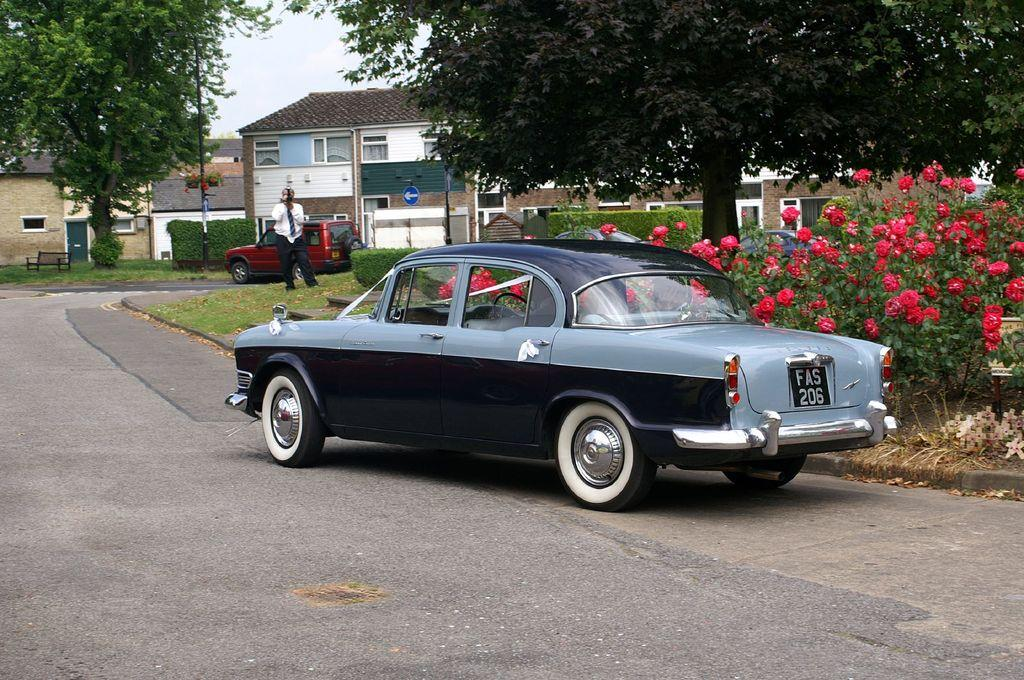What type of vehicle is on the road in the image? There is a black car on the road in the image. What can be seen on the right side of the image? There are red flower plants on the right side of the image. What structures are in the middle of the image? There are houses in the middle of the image. What is located on the left side of the image? There is a tree on the left side of the image. Can you see a receipt for the purchase of the car in the image? There is no receipt visible in the image. Is there a knife being used to cut the tree on the left side? There is no knife present in the image, and the tree is not being cut. 